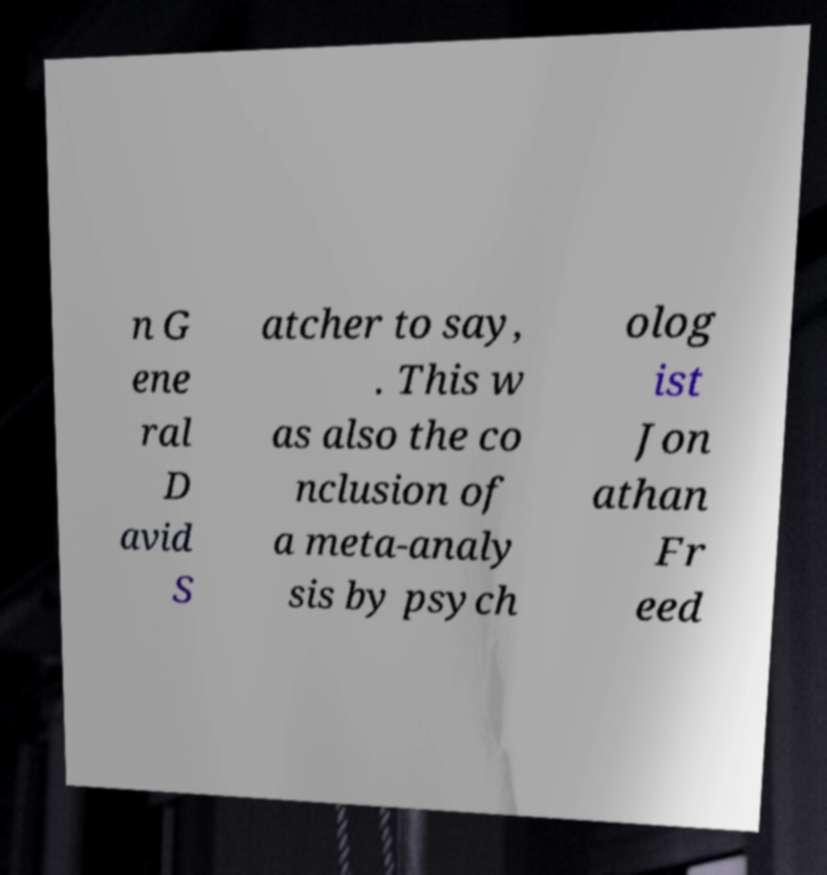Can you accurately transcribe the text from the provided image for me? n G ene ral D avid S atcher to say, . This w as also the co nclusion of a meta-analy sis by psych olog ist Jon athan Fr eed 